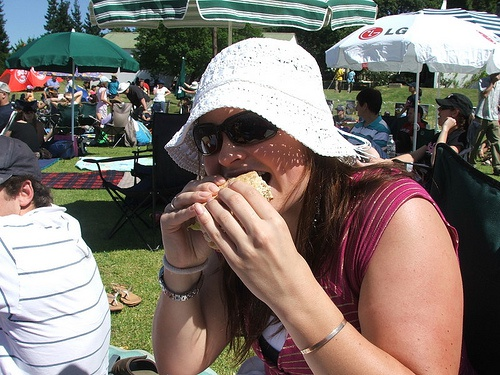Describe the objects in this image and their specific colors. I can see people in gray, black, tan, white, and maroon tones, people in gray, white, and darkgray tones, people in gray, black, darkgray, and lightgray tones, chair in gray, black, and teal tones, and umbrella in gray, white, darkgray, and lightblue tones in this image. 